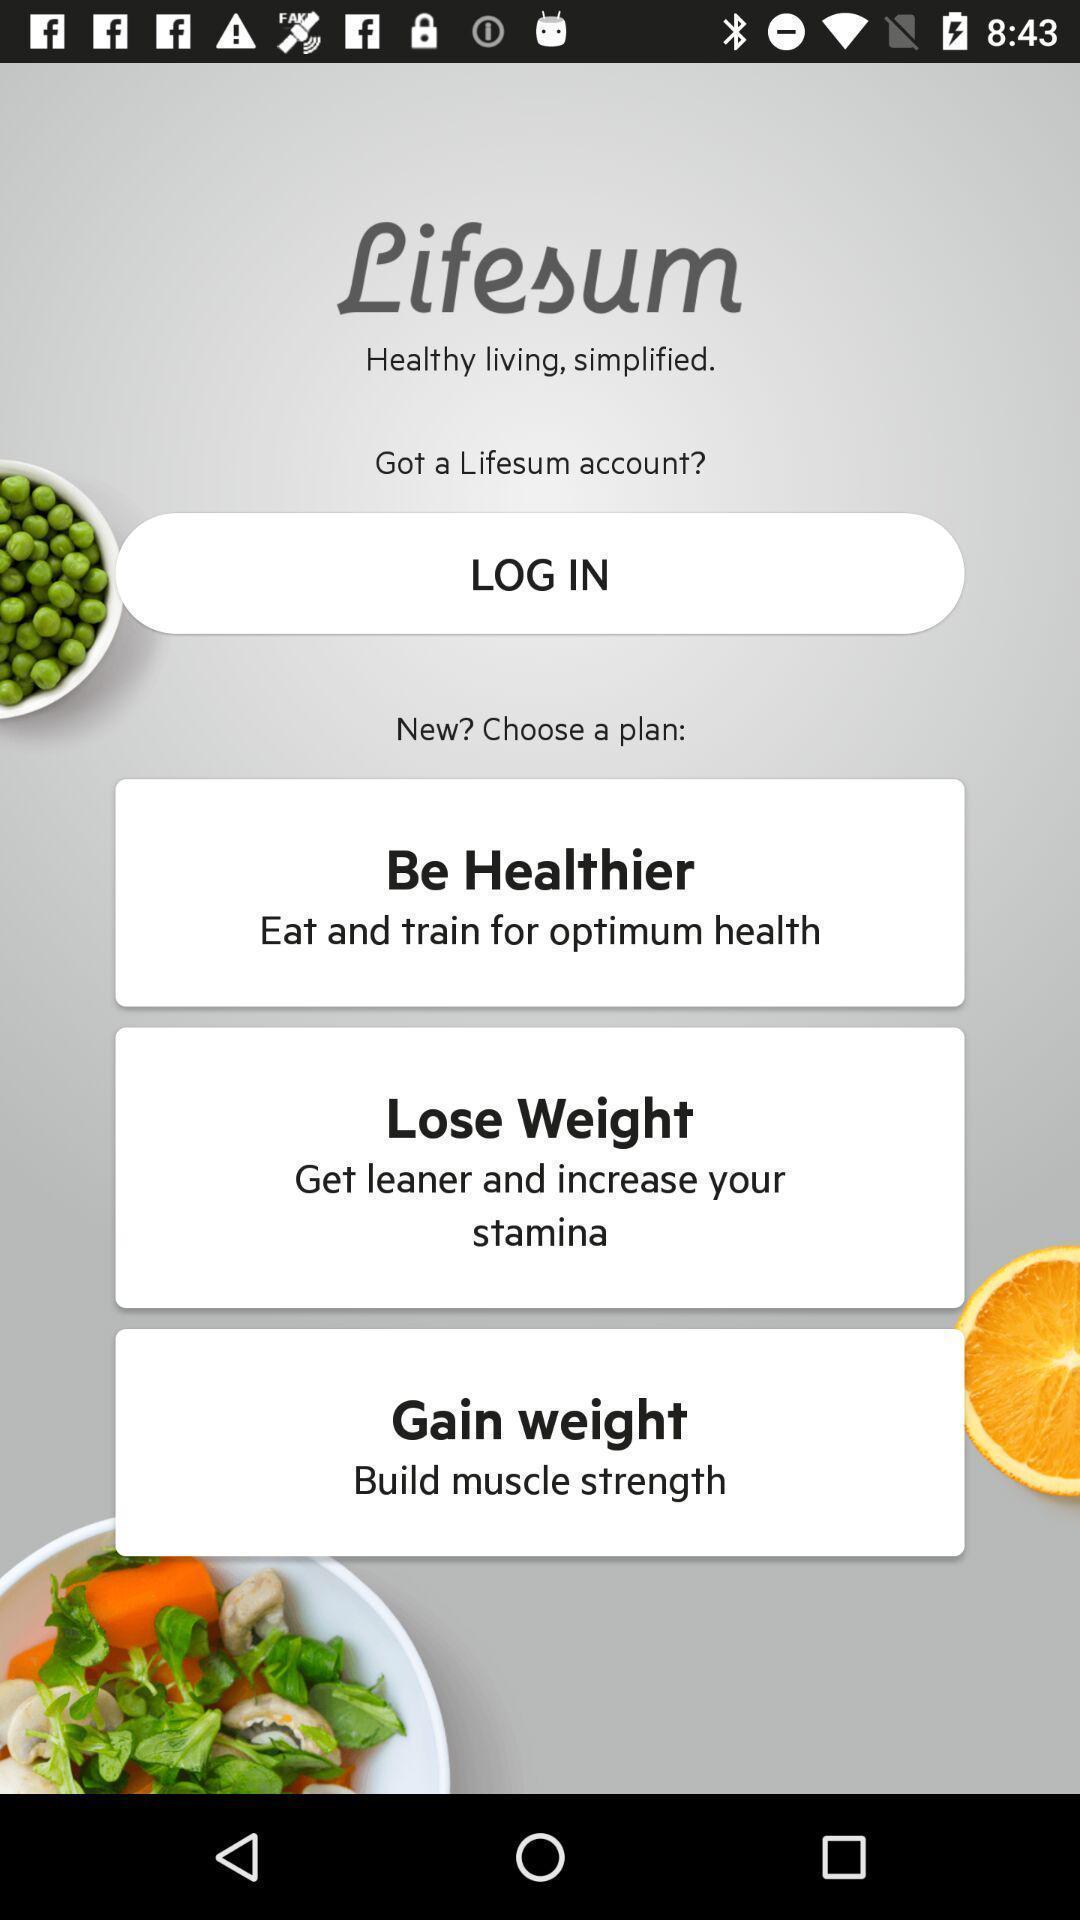Tell me what you see in this picture. Welcome page of a healthcare app. 